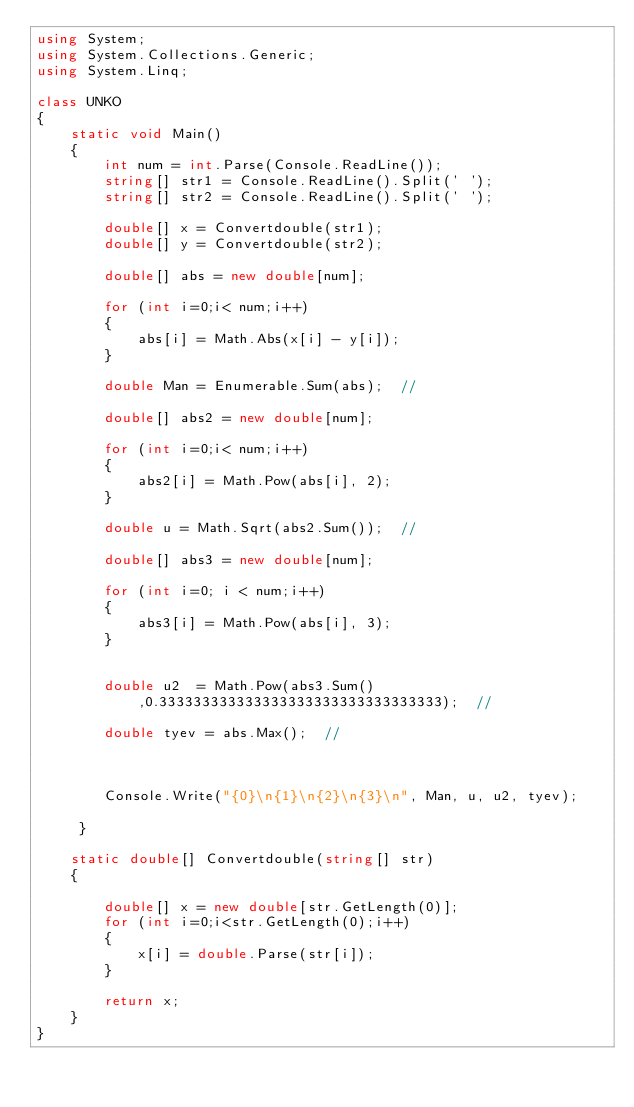<code> <loc_0><loc_0><loc_500><loc_500><_C#_>using System;
using System.Collections.Generic;
using System.Linq;

class UNKO
{
    static void Main()
    {
        int num = int.Parse(Console.ReadLine());
        string[] str1 = Console.ReadLine().Split(' ');
        string[] str2 = Console.ReadLine().Split(' ');

        double[] x = Convertdouble(str1);
        double[] y = Convertdouble(str2);

        double[] abs = new double[num];

        for (int i=0;i< num;i++)
        {
            abs[i] = Math.Abs(x[i] - y[i]);
        }

        double Man = Enumerable.Sum(abs);  //

        double[] abs2 = new double[num];

        for (int i=0;i< num;i++)
        {
            abs2[i] = Math.Pow(abs[i], 2);
        }

        double u = Math.Sqrt(abs2.Sum());  //

        double[] abs3 = new double[num];

        for (int i=0; i < num;i++)
        {
            abs3[i] = Math.Pow(abs[i], 3);
        }

        
        double u2  = Math.Pow(abs3.Sum(),0.333333333333333333333333333333333);  //

        double tyev = abs.Max();  //



        Console.Write("{0}\n{1}\n{2}\n{3}\n", Man, u, u2, tyev);

     }

    static double[] Convertdouble(string[] str)
    {

        double[] x = new double[str.GetLength(0)];
        for (int i=0;i<str.GetLength(0);i++)
        {
            x[i] = double.Parse(str[i]);
        }

        return x;
    }
}</code> 